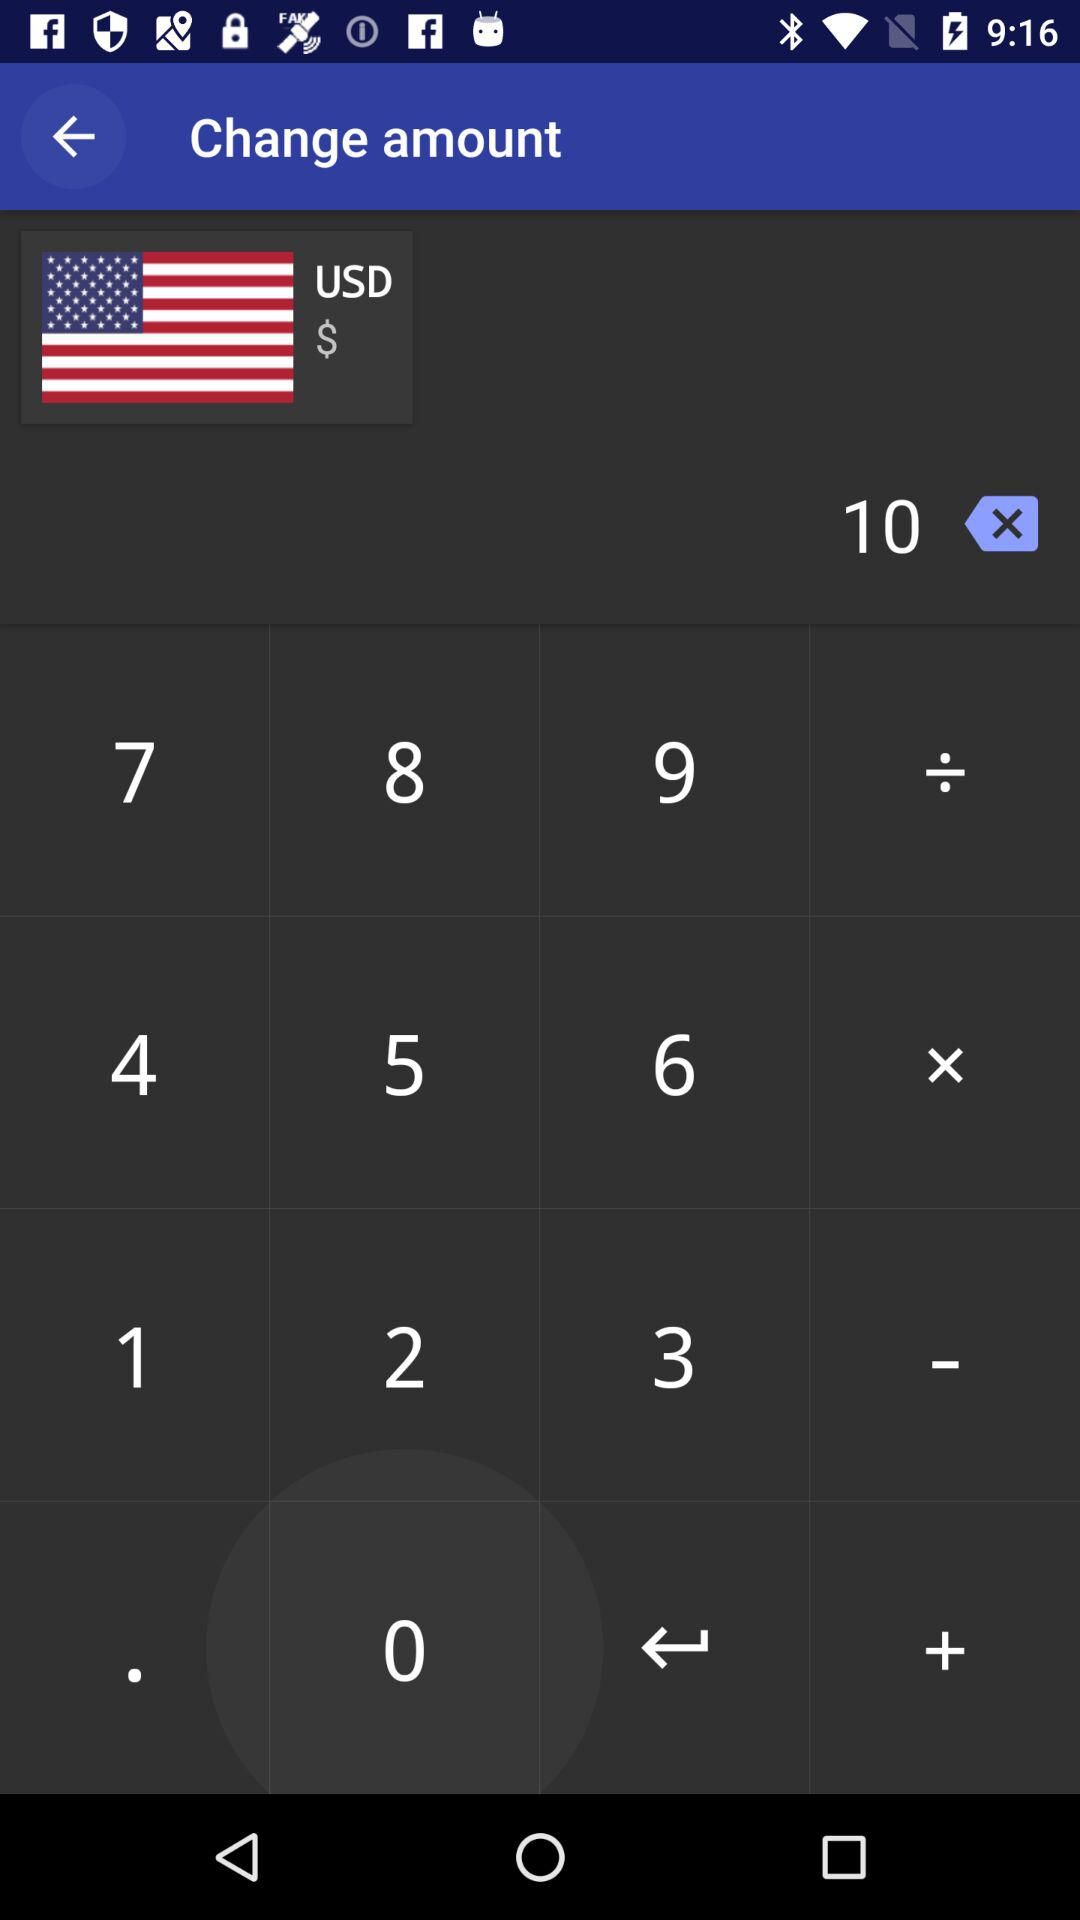What is the text in the input field? The text in the input field is "10". 